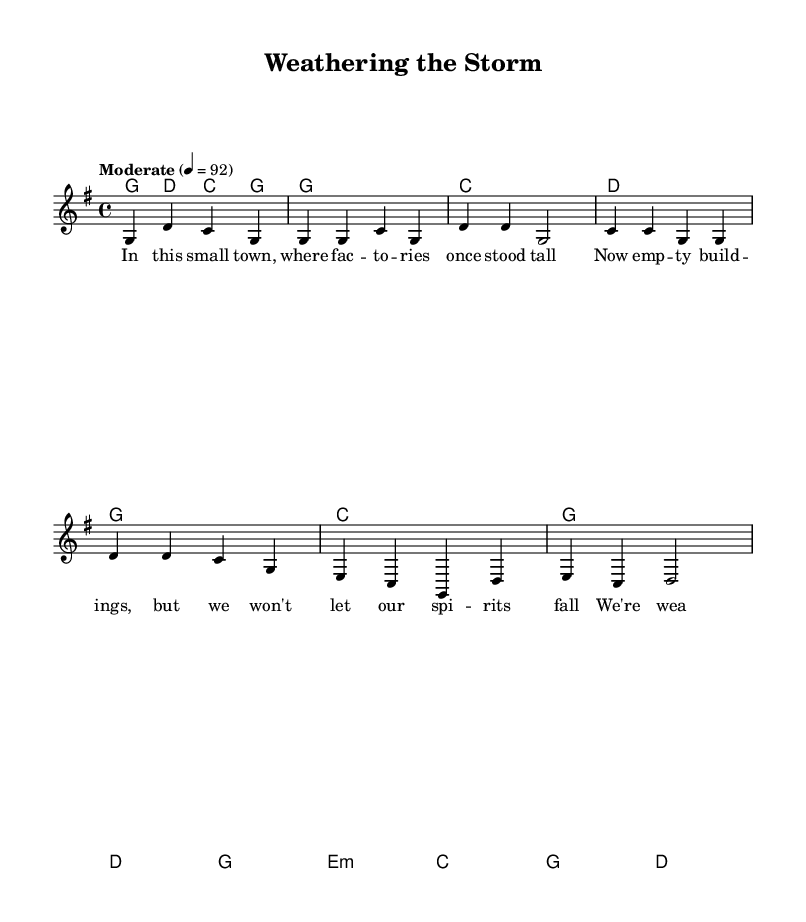What is the key signature of this music? The key signature is G major, which has one sharp (F#). You can determine this from the key signature indicated at the beginning of the staff.
Answer: G major What is the time signature of this music? The time signature is 4/4, which is clearly marked at the beginning of the piece. This means there are four beats in each measure, and the quarter note gets the beat.
Answer: 4/4 What is the tempo marking for this song? The tempo marking is "Moderate" with a metronome marking of 92 beats per minute. This indicates how fast the piece should be played and is found above the staff.
Answer: Moderate How many sections are there in the song? There are three distinct sections: Verse, Chorus, and Bridge. Each section is organized differently in the sheet music and denoted by the lyrics and chord structure.
Answer: Three Which chord is played during the verse? The chord played during the verse is G major. It is shown as the first chord on the staff and repeats throughout the verse structure.
Answer: G What emotion or theme does the chorus convey? The chorus conveys resilience and community pride, which is reflected in the lyrics celebrating togetherness in tough times. The overall tone suggests hope despite economic hardship.
Answer: Resilience What specific aspect of country music is highlighted in this piece? This piece highlights the theme of community solidarity, which is a common aspect of country music, often reflecting the struggles and resilience of rural communities.
Answer: Community solidarity 